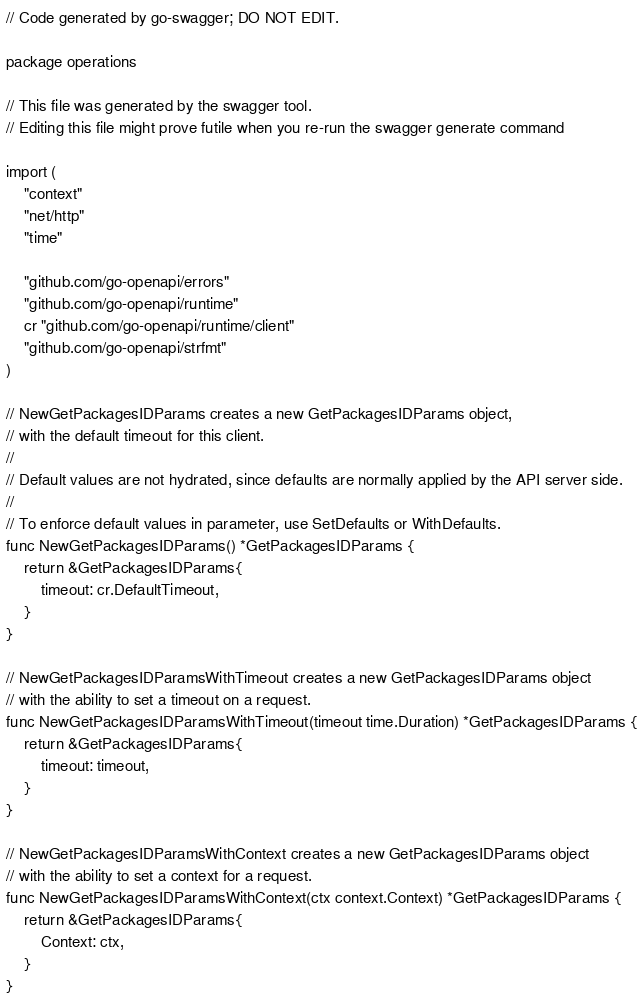Convert code to text. <code><loc_0><loc_0><loc_500><loc_500><_Go_>// Code generated by go-swagger; DO NOT EDIT.

package operations

// This file was generated by the swagger tool.
// Editing this file might prove futile when you re-run the swagger generate command

import (
	"context"
	"net/http"
	"time"

	"github.com/go-openapi/errors"
	"github.com/go-openapi/runtime"
	cr "github.com/go-openapi/runtime/client"
	"github.com/go-openapi/strfmt"
)

// NewGetPackagesIDParams creates a new GetPackagesIDParams object,
// with the default timeout for this client.
//
// Default values are not hydrated, since defaults are normally applied by the API server side.
//
// To enforce default values in parameter, use SetDefaults or WithDefaults.
func NewGetPackagesIDParams() *GetPackagesIDParams {
	return &GetPackagesIDParams{
		timeout: cr.DefaultTimeout,
	}
}

// NewGetPackagesIDParamsWithTimeout creates a new GetPackagesIDParams object
// with the ability to set a timeout on a request.
func NewGetPackagesIDParamsWithTimeout(timeout time.Duration) *GetPackagesIDParams {
	return &GetPackagesIDParams{
		timeout: timeout,
	}
}

// NewGetPackagesIDParamsWithContext creates a new GetPackagesIDParams object
// with the ability to set a context for a request.
func NewGetPackagesIDParamsWithContext(ctx context.Context) *GetPackagesIDParams {
	return &GetPackagesIDParams{
		Context: ctx,
	}
}
</code> 